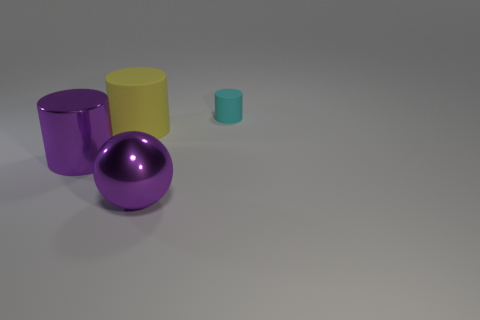How many objects are either small yellow matte objects or objects that are on the left side of the small rubber thing?
Offer a terse response. 3. There is a purple metallic thing that is in front of the large purple shiny cylinder; is it the same size as the matte thing that is on the right side of the yellow object?
Your response must be concise. No. How many other objects are there of the same color as the big matte cylinder?
Your answer should be compact. 0. There is a yellow rubber object; does it have the same size as the metal thing to the left of the big purple shiny sphere?
Make the answer very short. Yes. How big is the metal ball in front of the rubber thing that is in front of the small cyan cylinder?
Ensure brevity in your answer.  Large. What is the color of the large shiny object that is the same shape as the tiny object?
Provide a succinct answer. Purple. Does the yellow cylinder have the same size as the purple metal ball?
Your answer should be very brief. Yes. Are there the same number of small rubber cylinders on the left side of the big purple sphere and yellow cylinders?
Offer a terse response. No. Are there any spheres that are in front of the shiny object that is right of the large yellow rubber thing?
Provide a succinct answer. No. There is a cyan matte cylinder that is behind the shiny object to the right of the rubber thing that is on the left side of the cyan cylinder; what size is it?
Offer a terse response. Small. 